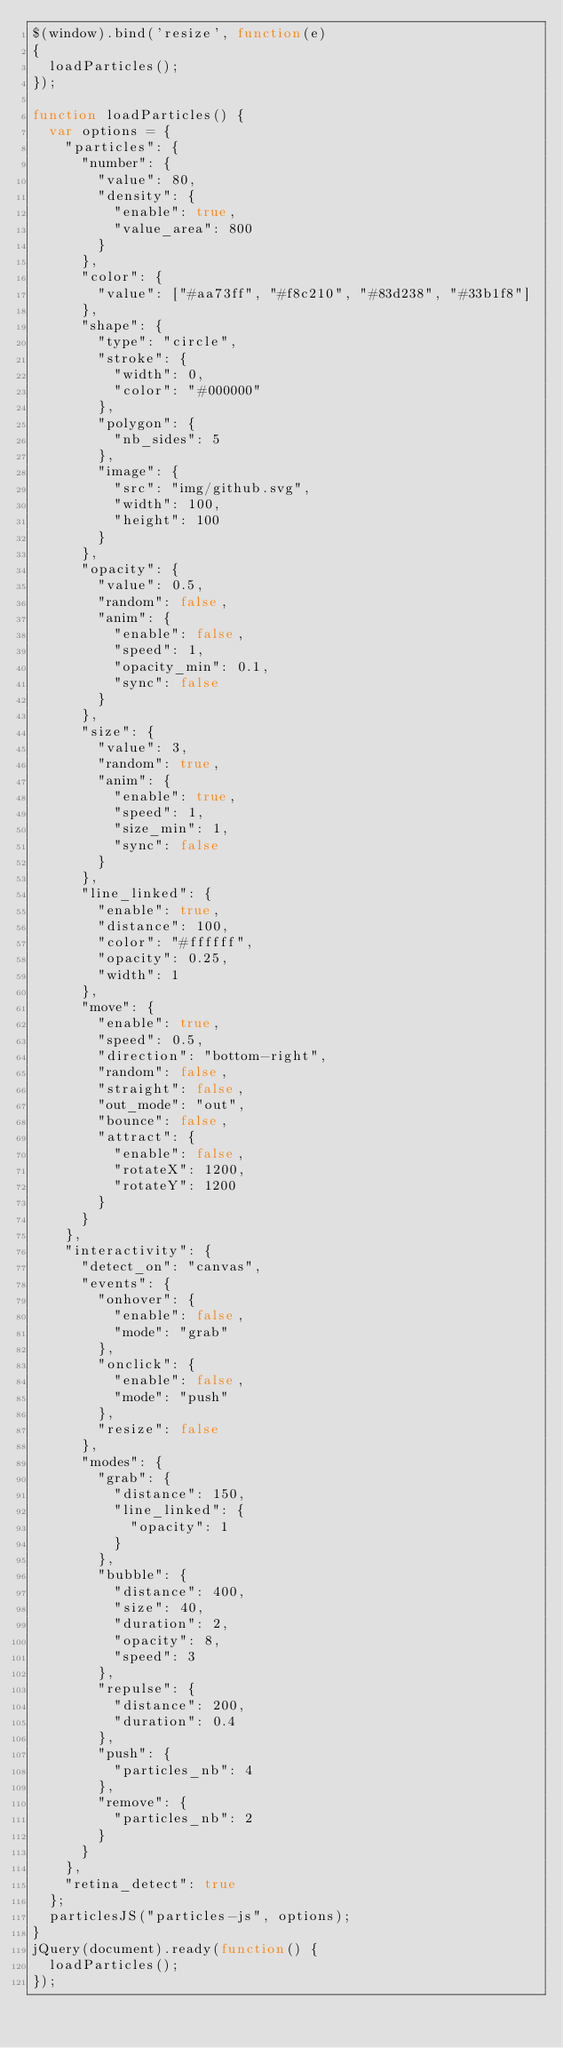<code> <loc_0><loc_0><loc_500><loc_500><_JavaScript_>$(window).bind('resize', function(e)
{
  loadParticles();
});

function loadParticles() {
  var options = {
    "particles": {
      "number": {
        "value": 80,
        "density": {
          "enable": true,
          "value_area": 800
        }
      },
      "color": {
        "value": ["#aa73ff", "#f8c210", "#83d238", "#33b1f8"]
      },
      "shape": {
        "type": "circle",
        "stroke": {
          "width": 0,
          "color": "#000000"
        },
        "polygon": {
          "nb_sides": 5
        },
        "image": {
          "src": "img/github.svg",
          "width": 100,
          "height": 100
        }
      },
      "opacity": {
        "value": 0.5,
        "random": false,
        "anim": {
          "enable": false,
          "speed": 1,
          "opacity_min": 0.1,
          "sync": false
        }
      },
      "size": {
        "value": 3,
        "random": true,
        "anim": {
          "enable": true,
          "speed": 1,
          "size_min": 1,
          "sync": false
        }
      },
      "line_linked": {
        "enable": true,
        "distance": 100,
        "color": "#ffffff",
        "opacity": 0.25,
        "width": 1
      },
      "move": {
        "enable": true,
        "speed": 0.5,
        "direction": "bottom-right",
        "random": false,
        "straight": false,
        "out_mode": "out",
        "bounce": false,
        "attract": {
          "enable": false,
          "rotateX": 1200,
          "rotateY": 1200
        }
      }
    },
    "interactivity": {
      "detect_on": "canvas",
      "events": {
        "onhover": {
          "enable": false,
          "mode": "grab"
        },
        "onclick": {
          "enable": false,
          "mode": "push"
        },
        "resize": false
      },
      "modes": {
        "grab": {
          "distance": 150,
          "line_linked": {
            "opacity": 1
          }
        },
        "bubble": {
          "distance": 400,
          "size": 40,
          "duration": 2,
          "opacity": 8,
          "speed": 3
        },
        "repulse": {
          "distance": 200,
          "duration": 0.4
        },
        "push": {
          "particles_nb": 4
        },
        "remove": {
          "particles_nb": 2
        }
      }
    },
    "retina_detect": true
  };
  particlesJS("particles-js", options);
}
jQuery(document).ready(function() {
  loadParticles();
});</code> 